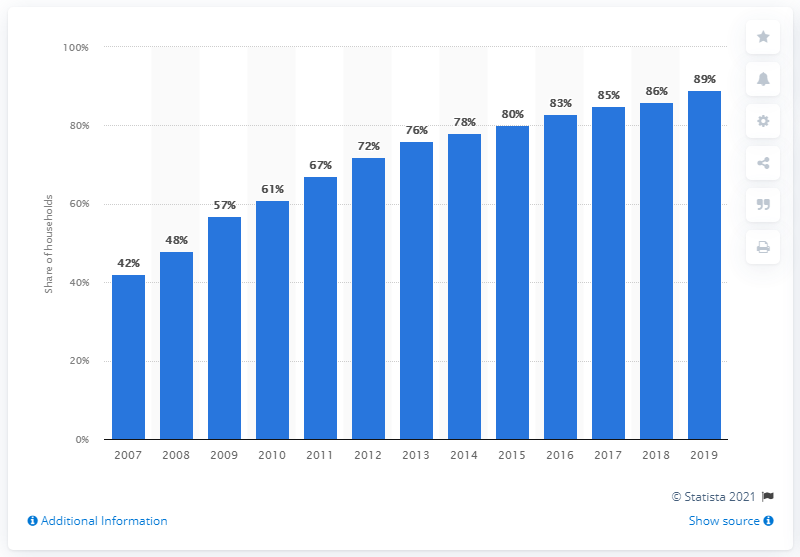Highlight a few significant elements in this photo. In 2019, there was a significant increase in broadband internet usage in the EU-28, with a rise of 89%. In 2019, 89% of households in the EU-28 had access to broadband internet. 